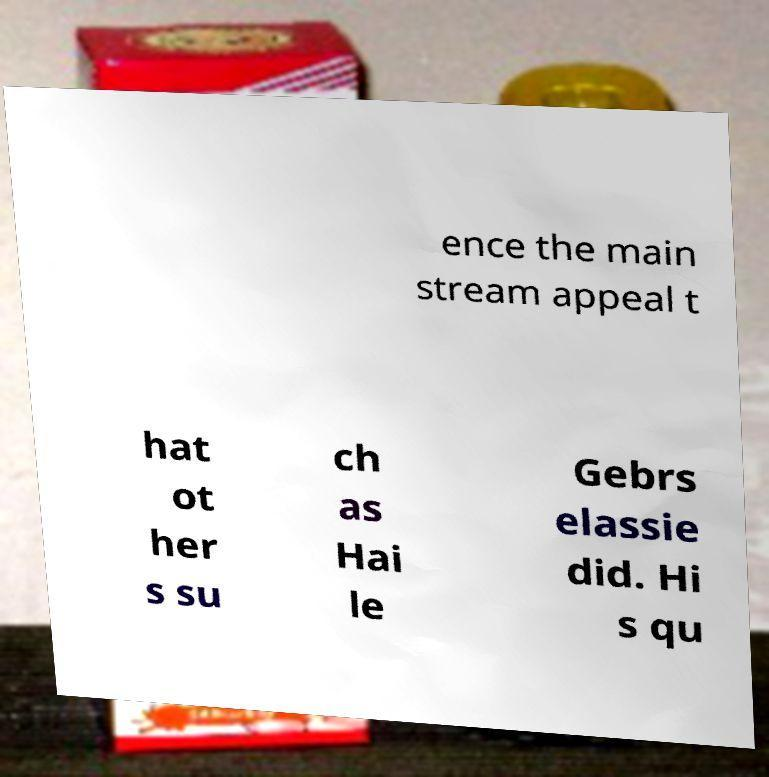Please read and relay the text visible in this image. What does it say? ence the main stream appeal t hat ot her s su ch as Hai le Gebrs elassie did. Hi s qu 